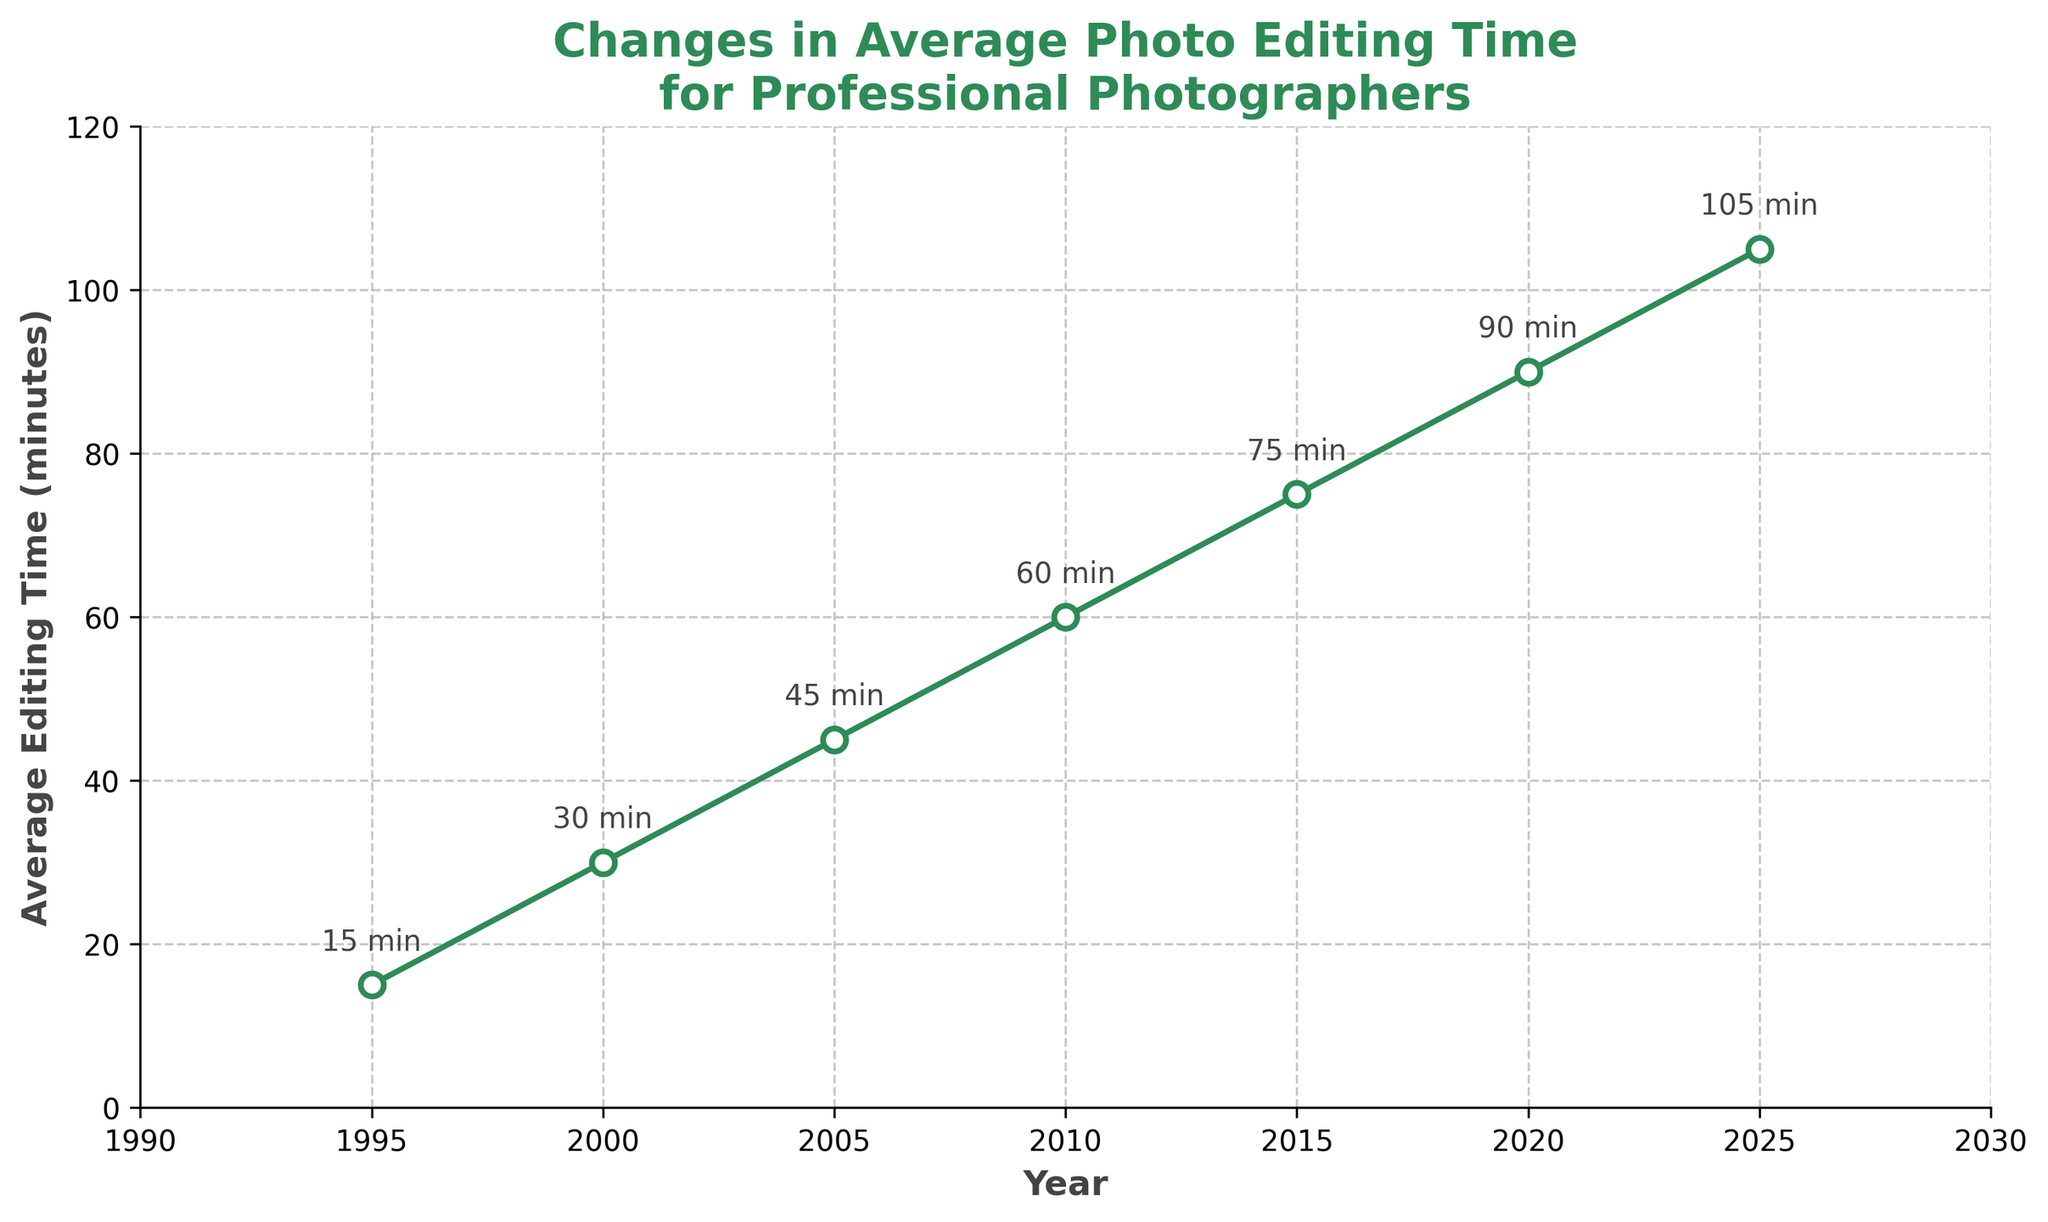What is the average photo editing time for the year 2010? Locate the year 2010 on the x-axis and find the corresponding average editing time on the y-axis, which is 60 minutes.
Answer: 60 minutes How much did the average editing time increase from 1995 to 2025? Find the values for 1995 and 2025, then calculate the difference (105 - 15).
Answer: 90 minutes Between which years does the graph show the greatest increase in average editing time? Compare the differences between every consecutive pair of years in the dataset (e.g., 2000-1995, 2005-2000, etc.) to find the largest increase, which occurs between each pair of consecutive years (+15 minutes consistently).
Answer: Each 5-year increase is consistent In which year did the average editing time reached 75 minutes? Locate the value 75 minutes on the y-axis and find the corresponding year, which is 2015.
Answer: 2015 By how many minutes did the editing time increase between 2000 and 2010? Subtract the editing time in 2000 from that in 2010 (60 - 30).
Answer: 30 minutes What is the color of the line representing the average editing time? Observe the color of the plotted line in the figure, which is green.
Answer: Green During which 10-year period did the average editing time increase by 30 minutes? Compare each 10-year period increment and find the one where editing time increased by 30 minutes, which is 2000 to 2010 (30 to 60).
Answer: 2000 to 2010 What is the slope of the line between 2005 and 2010? The change in editing time divided by the change in time (years): (60 - 45) / (2010 - 2005) = 15/5 = 3 minutes per year.
Answer: 3 minutes per year How does the average photo editing time in 2020 compare to that in 1995? Compare the values for 2020 (90 minutes) and for 1995 (15 minutes), noting that 2020's value is significantly higher.
Answer: 2020 is higher What trend can be observed in the average photo editing time from 1995 to 2025? The editing time shows a consistent upward trend, increasing by 15 minutes every 5 years.
Answer: Consistent increase 